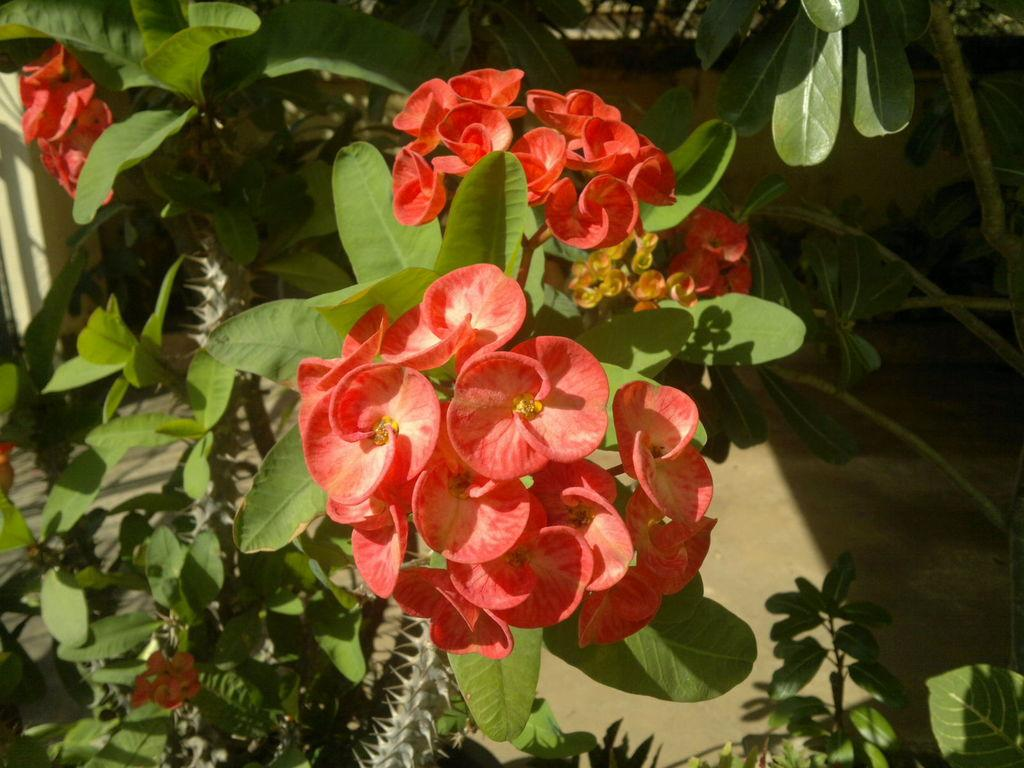What type of living organisms can be seen in the image? There are flowers and plants in the image. Can you describe the plants in the image? The plants in the image are not specified, but they are present alongside the flowers. What type of owl can be seen in the image? There is no owl present in the image; it only features flowers and plants. 